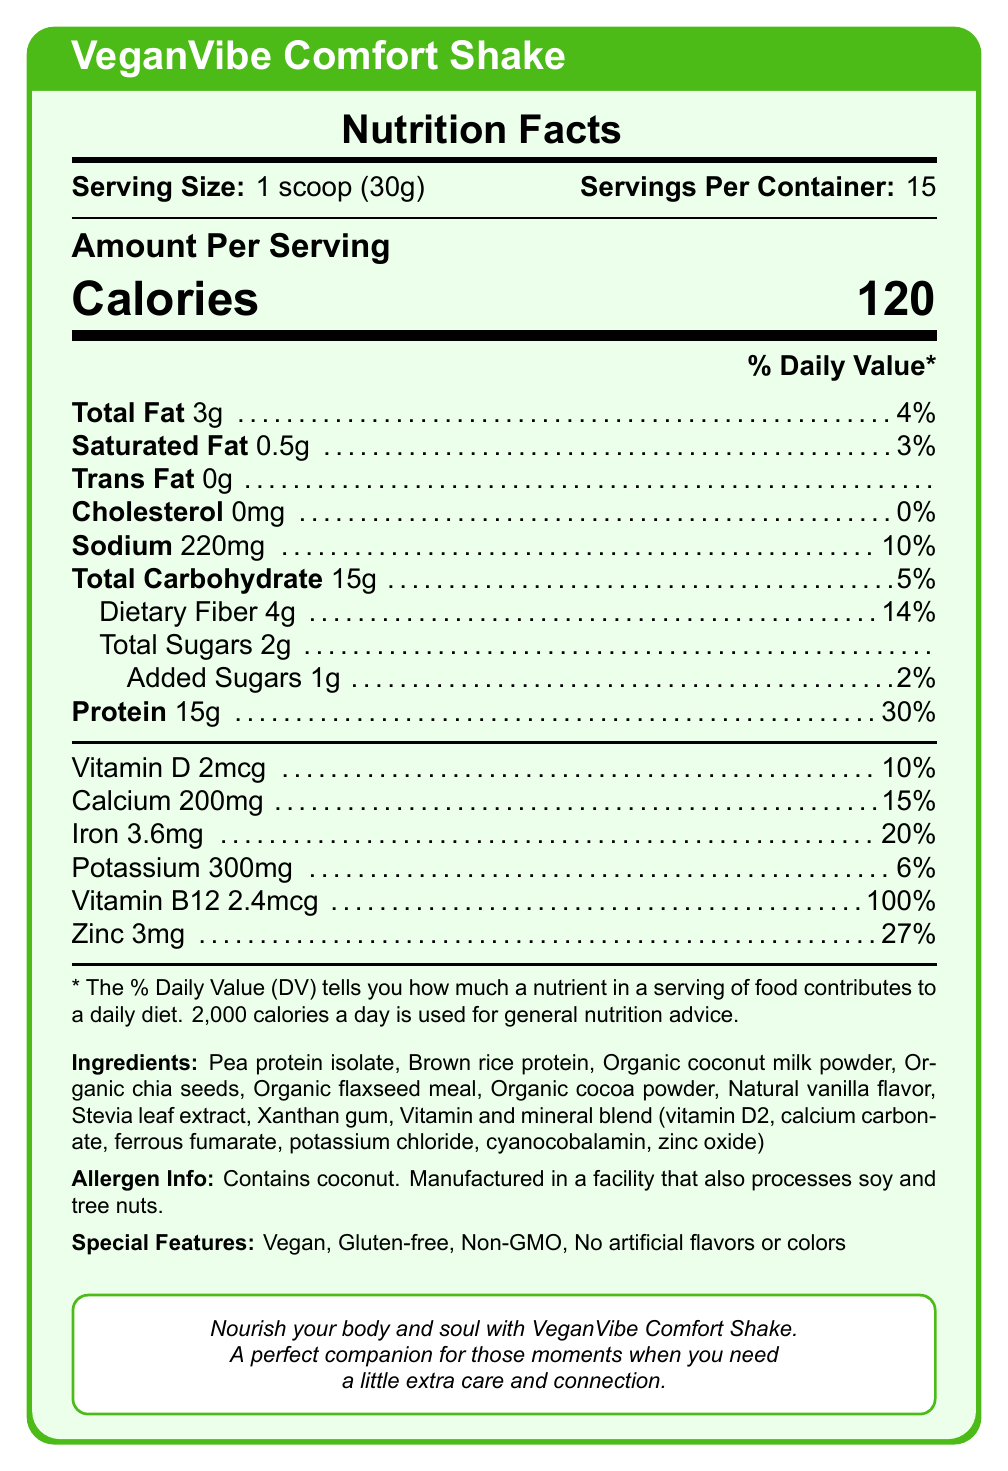what is the serving size? The document indicates under Nutrition Facts that the serving size is 1 scoop (30g).
Answer: 1 scoop (30g) how many calories are in one serving? The document specifies that there are 120 calories per serving in the Nutrition Facts section.
Answer: 120 how much protein does one serving contain? The document lists protein content as 15g in the Nutrition Facts section.
Answer: 15g are there any artificial flavors or colors in this product? The Special Features section clearly states "No artificial flavors or colors."
Answer: No what allergen does this shake contain? Under Allergen Info, the document mentions the shake contains coconut.
Answer: Coconut what percentage of the daily value is the dietary fiber content? The Nutrition Facts section shows that the dietary fiber content is 14% of the daily value.
Answer: 14% what is the serving size? A. 20g B. 25g C. 30g D. 35g The serving size listed in the document is 1 scoop (30g), which corresponds to option C.
Answer: C how many servings are in one container? A. 10 B. 15 C. 20 D. 25 The document states there are 15 servings per container, making option B correct.
Answer: B is this shake gluten-free? The Special Features section mentions that the product is gluten-free.
Answer: Yes is cholesterol present in this product? The Nutrition Facts label indicates that there is 0mg of cholesterol.
Answer: No summarize the main idea of this document. The document provides detailed nutritional information, ingredients, allergen information, special features, and an emotional support message for the VeganVibe Comfort Shake.
Answer: VeganVibe Comfort Shake is a vegan, gluten-free, non-GMO meal replacement shake with no artificial flavors or colors, marketed as a comforting and nutritious option, especially for those who want extra care and connection. what is the source of the cocoa powder in this shake? The document only mentions "Organic cocoa powder" in the ingredients but doesn't specify the source.
Answer: Cannot be determined does the product contain any added sugars? what amount? The Nutrition Facts section lists added sugars as 1g per serving, contributing 2% of the daily value.
Answer: Yes, 1g what is the amount of calcium in a serving? The Nutrition Facts section specifies 200mg of calcium per serving, which is 15% of the daily value.
Answer: 200mg list three main protein sources in this product. The Ingredients section lists "Pea protein isolate," "Brown rice protein," and "Organic coconut milk powder" as protein sources.
Answer: Pea protein isolate, Brown rice protein, Organic coconut milk powder 